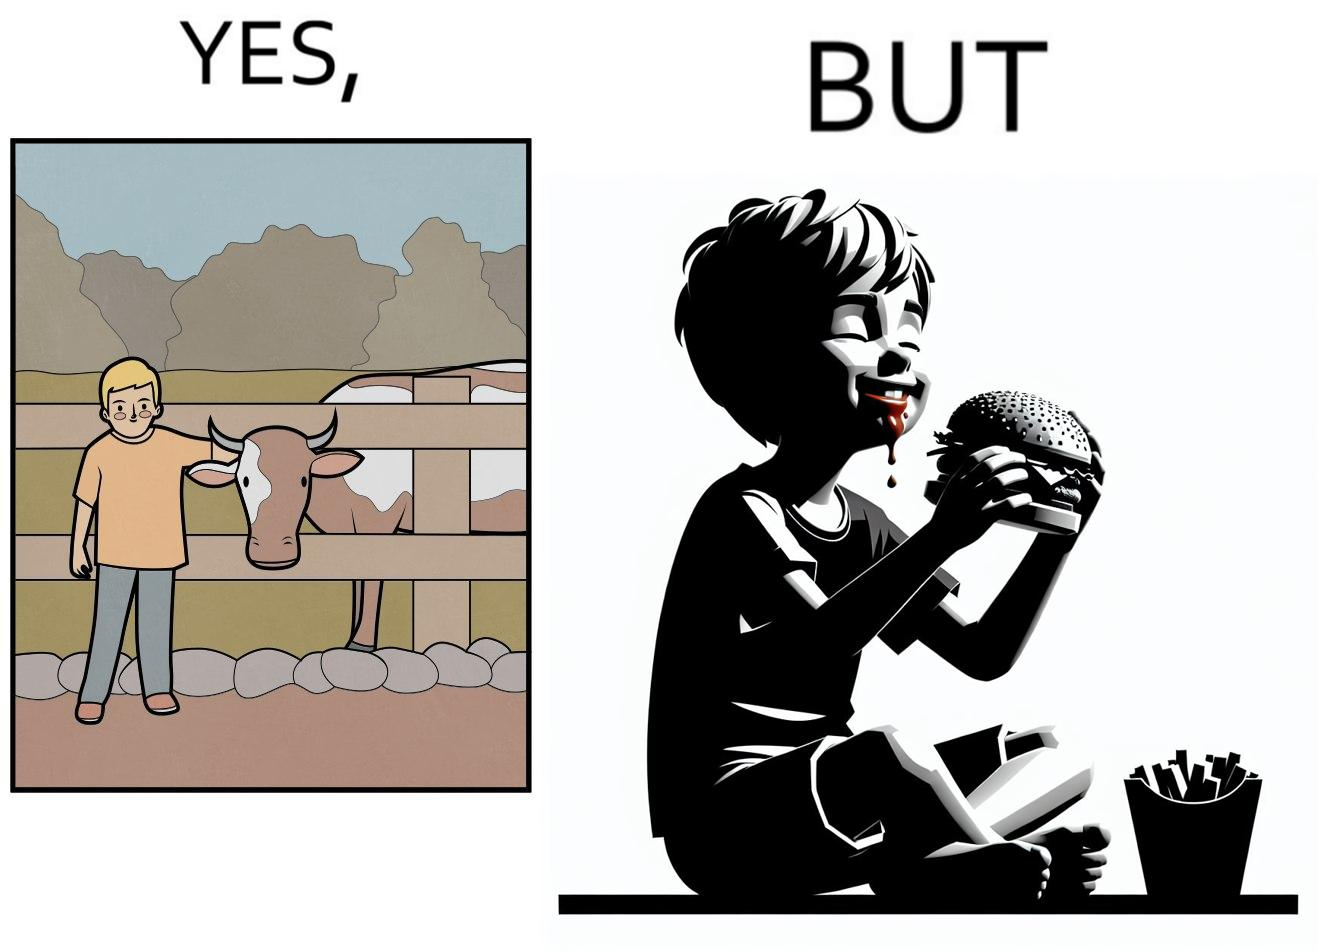Compare the left and right sides of this image. In the left part of the image: A boy petting a cow In the right part of the image: A boy eating a hamburger 